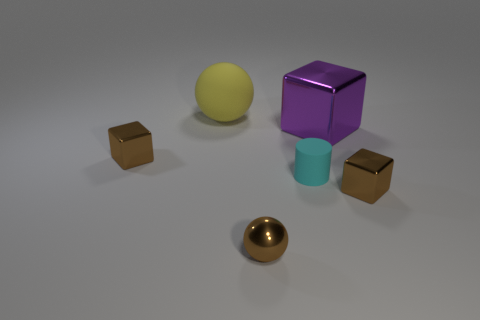Is there a object of the same color as the small shiny ball?
Give a very brief answer. Yes. Is there anything else that has the same color as the big metal cube?
Your response must be concise. No. What number of cyan objects are there?
Your answer should be very brief. 1. The thing that is on the right side of the tiny cyan rubber thing and in front of the purple metallic thing has what shape?
Your answer should be compact. Cube. What shape is the rubber thing behind the brown metal cube behind the tiny cyan thing that is on the right side of the tiny brown metallic ball?
Offer a very short reply. Sphere. What is the material of the tiny brown object that is both behind the small brown metallic ball and to the right of the yellow ball?
Your response must be concise. Metal. What number of brown objects have the same size as the purple thing?
Provide a succinct answer. 0. What number of rubber objects are either tiny balls or large blocks?
Ensure brevity in your answer.  0. What is the material of the big yellow ball?
Provide a succinct answer. Rubber. What number of yellow matte objects are in front of the tiny ball?
Give a very brief answer. 0. 